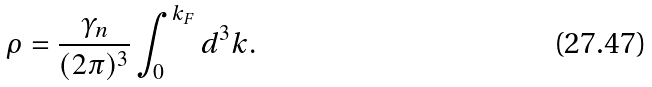Convert formula to latex. <formula><loc_0><loc_0><loc_500><loc_500>\rho = \frac { \gamma _ { n } } { ( 2 \pi ) ^ { 3 } } \int ^ { k _ { F } } _ { 0 } d ^ { 3 } k .</formula> 